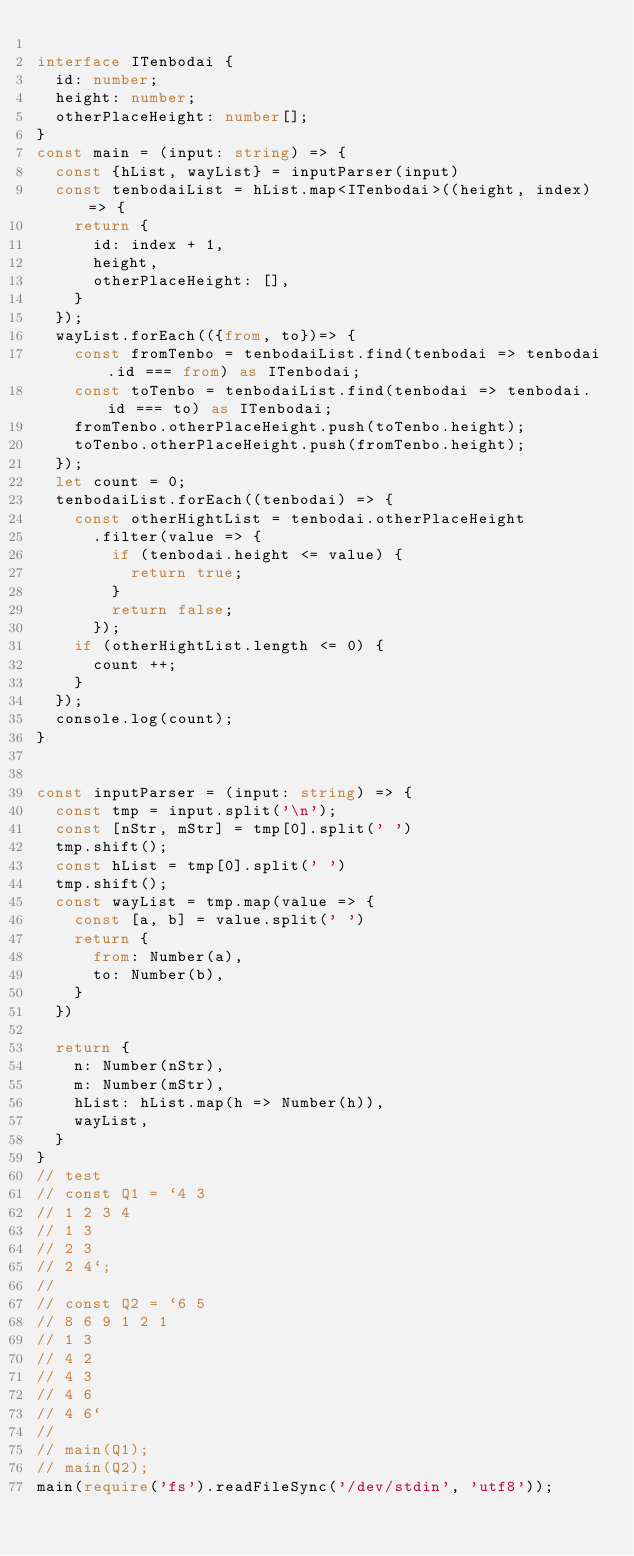<code> <loc_0><loc_0><loc_500><loc_500><_TypeScript_>
interface ITenbodai {
  id: number;
  height: number;
  otherPlaceHeight: number[];
}
const main = (input: string) => {
  const {hList, wayList} = inputParser(input)
  const tenbodaiList = hList.map<ITenbodai>((height, index) => {
    return {
      id: index + 1,
      height,
      otherPlaceHeight: [],
    }
  });
  wayList.forEach(({from, to})=> {
    const fromTenbo = tenbodaiList.find(tenbodai => tenbodai.id === from) as ITenbodai;
    const toTenbo = tenbodaiList.find(tenbodai => tenbodai.id === to) as ITenbodai;
    fromTenbo.otherPlaceHeight.push(toTenbo.height);
    toTenbo.otherPlaceHeight.push(fromTenbo.height);
  });
  let count = 0;
  tenbodaiList.forEach((tenbodai) => {
    const otherHightList = tenbodai.otherPlaceHeight
      .filter(value => {
        if (tenbodai.height <= value) {
          return true;
        }
        return false;
      });
    if (otherHightList.length <= 0) {
      count ++;
    }
  });
  console.log(count);
}


const inputParser = (input: string) => {
  const tmp = input.split('\n');
  const [nStr, mStr] = tmp[0].split(' ')
  tmp.shift();
  const hList = tmp[0].split(' ')
  tmp.shift();
  const wayList = tmp.map(value => {
    const [a, b] = value.split(' ')
    return {
      from: Number(a),
      to: Number(b),
    }
  })

  return {
    n: Number(nStr),
    m: Number(mStr),
    hList: hList.map(h => Number(h)),
    wayList,
  }
}
// test
// const Q1 = `4 3
// 1 2 3 4
// 1 3
// 2 3
// 2 4`;
// 
// const Q2 = `6 5
// 8 6 9 1 2 1
// 1 3
// 4 2
// 4 3
// 4 6
// 4 6`
// 
// main(Q1);
// main(Q2);
main(require('fs').readFileSync('/dev/stdin', 'utf8'));</code> 